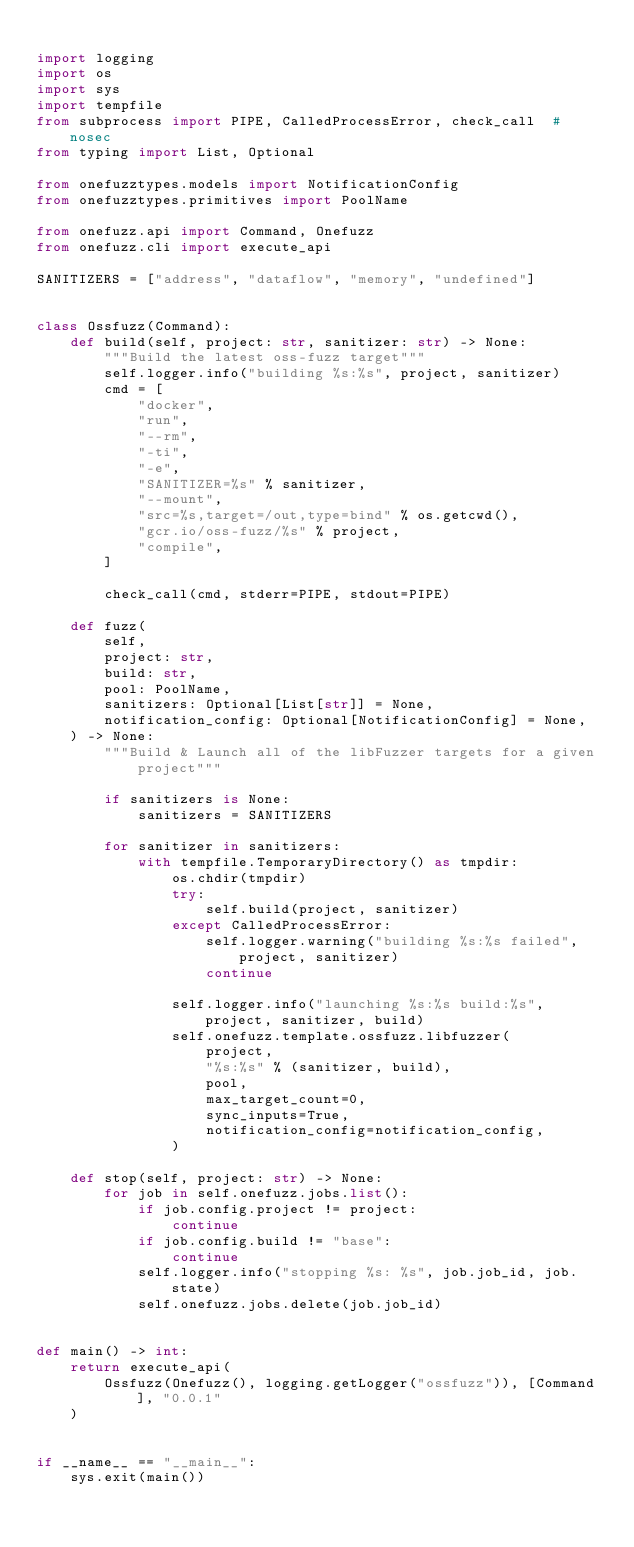<code> <loc_0><loc_0><loc_500><loc_500><_Python_>
import logging
import os
import sys
import tempfile
from subprocess import PIPE, CalledProcessError, check_call  # nosec
from typing import List, Optional

from onefuzztypes.models import NotificationConfig
from onefuzztypes.primitives import PoolName

from onefuzz.api import Command, Onefuzz
from onefuzz.cli import execute_api

SANITIZERS = ["address", "dataflow", "memory", "undefined"]


class Ossfuzz(Command):
    def build(self, project: str, sanitizer: str) -> None:
        """Build the latest oss-fuzz target"""
        self.logger.info("building %s:%s", project, sanitizer)
        cmd = [
            "docker",
            "run",
            "--rm",
            "-ti",
            "-e",
            "SANITIZER=%s" % sanitizer,
            "--mount",
            "src=%s,target=/out,type=bind" % os.getcwd(),
            "gcr.io/oss-fuzz/%s" % project,
            "compile",
        ]

        check_call(cmd, stderr=PIPE, stdout=PIPE)

    def fuzz(
        self,
        project: str,
        build: str,
        pool: PoolName,
        sanitizers: Optional[List[str]] = None,
        notification_config: Optional[NotificationConfig] = None,
    ) -> None:
        """Build & Launch all of the libFuzzer targets for a given project"""

        if sanitizers is None:
            sanitizers = SANITIZERS

        for sanitizer in sanitizers:
            with tempfile.TemporaryDirectory() as tmpdir:
                os.chdir(tmpdir)
                try:
                    self.build(project, sanitizer)
                except CalledProcessError:
                    self.logger.warning("building %s:%s failed", project, sanitizer)
                    continue

                self.logger.info("launching %s:%s build:%s", project, sanitizer, build)
                self.onefuzz.template.ossfuzz.libfuzzer(
                    project,
                    "%s:%s" % (sanitizer, build),
                    pool,
                    max_target_count=0,
                    sync_inputs=True,
                    notification_config=notification_config,
                )

    def stop(self, project: str) -> None:
        for job in self.onefuzz.jobs.list():
            if job.config.project != project:
                continue
            if job.config.build != "base":
                continue
            self.logger.info("stopping %s: %s", job.job_id, job.state)
            self.onefuzz.jobs.delete(job.job_id)


def main() -> int:
    return execute_api(
        Ossfuzz(Onefuzz(), logging.getLogger("ossfuzz")), [Command], "0.0.1"
    )


if __name__ == "__main__":
    sys.exit(main())
</code> 